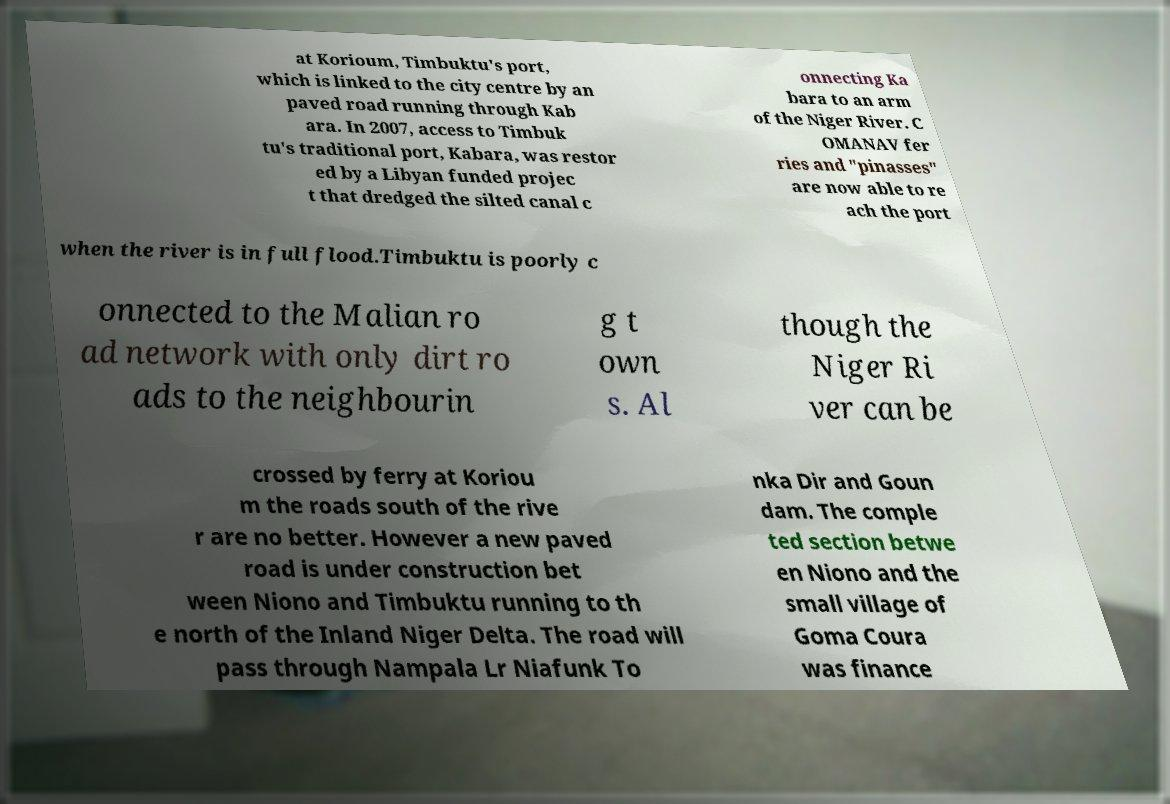What messages or text are displayed in this image? I need them in a readable, typed format. at Korioum, Timbuktu's port, which is linked to the city centre by an paved road running through Kab ara. In 2007, access to Timbuk tu's traditional port, Kabara, was restor ed by a Libyan funded projec t that dredged the silted canal c onnecting Ka bara to an arm of the Niger River. C OMANAV fer ries and "pinasses" are now able to re ach the port when the river is in full flood.Timbuktu is poorly c onnected to the Malian ro ad network with only dirt ro ads to the neighbourin g t own s. Al though the Niger Ri ver can be crossed by ferry at Koriou m the roads south of the rive r are no better. However a new paved road is under construction bet ween Niono and Timbuktu running to th e north of the Inland Niger Delta. The road will pass through Nampala Lr Niafunk To nka Dir and Goun dam. The comple ted section betwe en Niono and the small village of Goma Coura was finance 